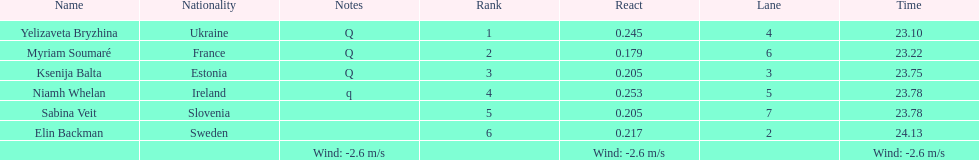Which athlete is from sweden? Elin Backman. What was their time to finish the race? 24.13. 